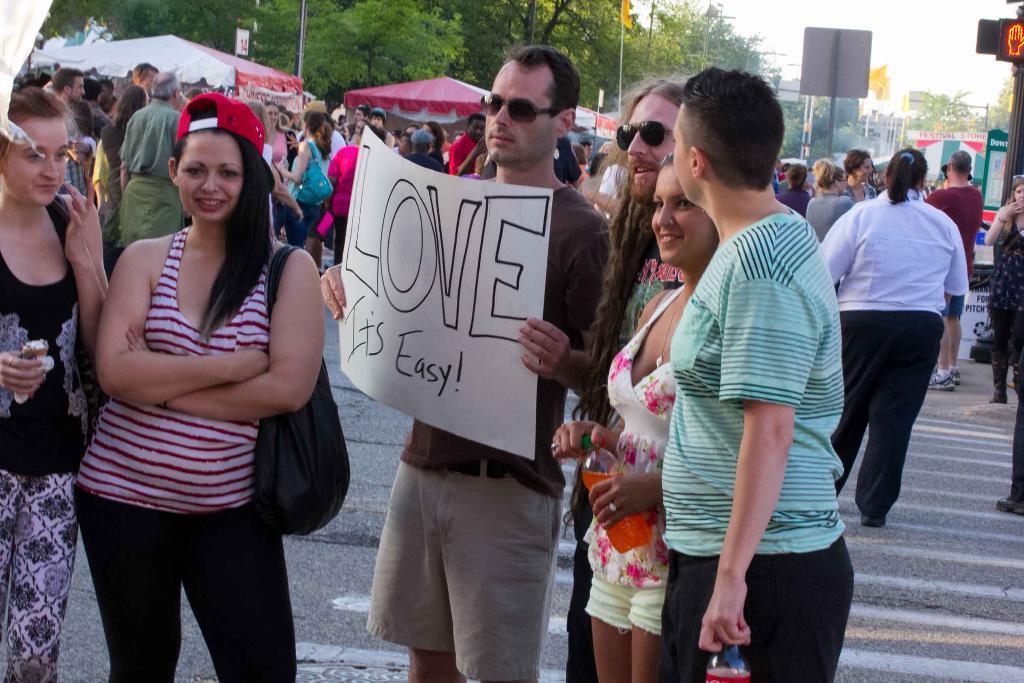Can you describe this image briefly? In this image we can see a person holding a chart. We can also see some people around him. Two people are holding bottles. On the backside we can see a group of people, some tents, board, a sign board, trees, pole and the sky. 